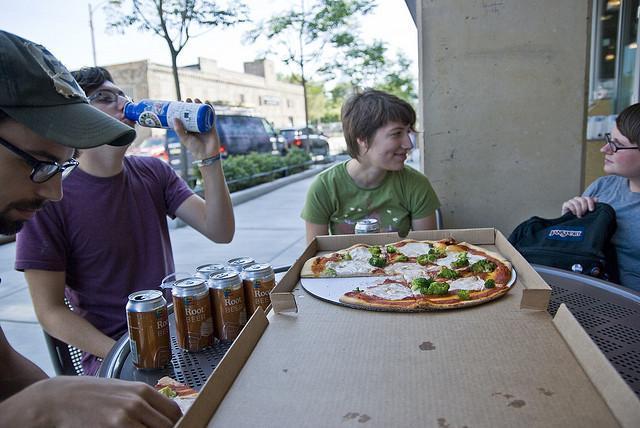How many are wearing glasses?
Give a very brief answer. 3. How many handbags are there?
Give a very brief answer. 1. How many dining tables can you see?
Give a very brief answer. 2. How many people are there?
Give a very brief answer. 4. 